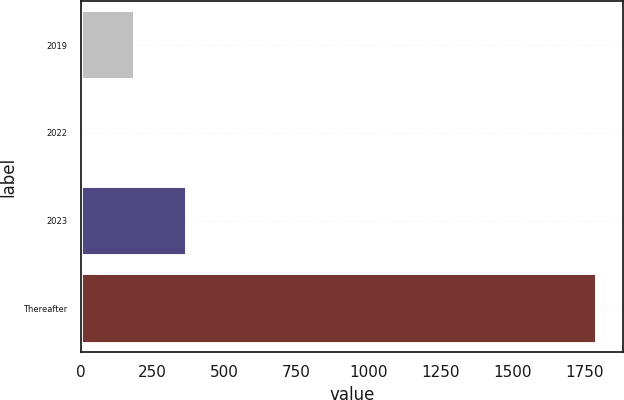Convert chart. <chart><loc_0><loc_0><loc_500><loc_500><bar_chart><fcel>2019<fcel>2022<fcel>2023<fcel>Thereafter<nl><fcel>188.5<fcel>0.4<fcel>370.8<fcel>1794.3<nl></chart> 